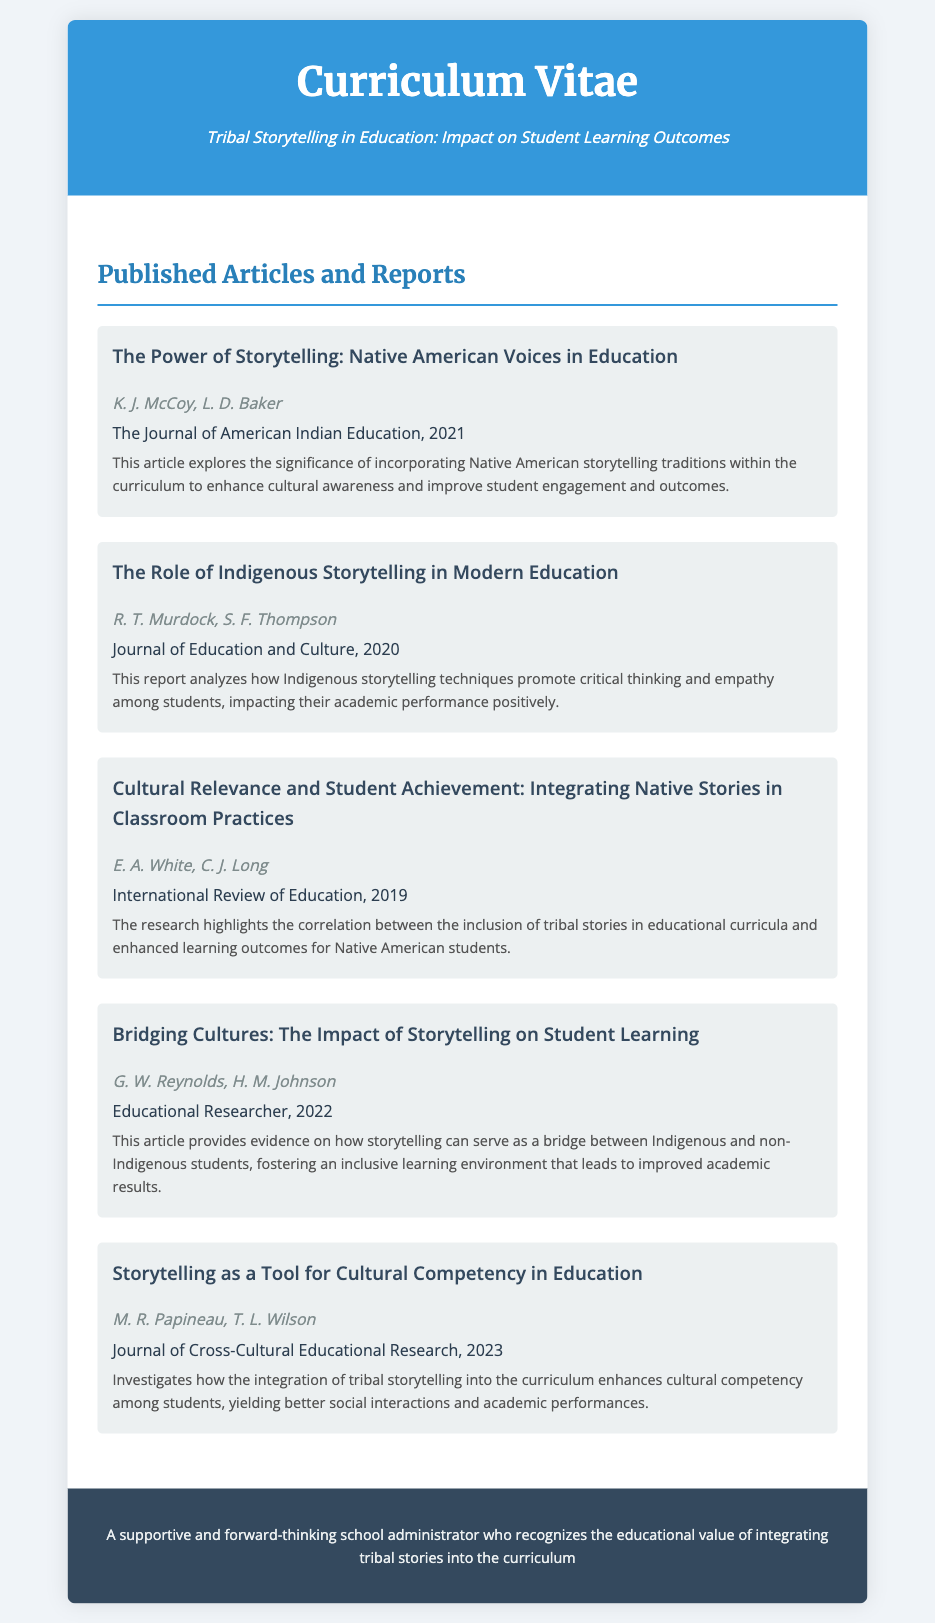What is the title of the first article? The title can be found at the beginning of the article section, listing the relevant information.
Answer: The Power of Storytelling: Native American Voices in Education Who are the authors of the article published in 2023? The authors can be identified under the respective article title, specifically for the published year mentioned.
Answer: M. R. Papineau, T. L. Wilson In what year was the article "Cultural Relevance and Student Achievement: Integrating Native Stories in Classroom Practices" published? This information is stated directly after the title of the article in the document.
Answer: 2019 Which journal published the report analyzing Indigenous storytelling techniques? The journal's name is mentioned after the article title and authors, relevant to the specific report.
Answer: Journal of Education and Culture What is a key outcome of integrating tribal storytelling into education according to the articles? This insight can be gathered from the impact descriptions under each article, reflecting overall findings.
Answer: Enhanced cultural awareness How many articles were published in the year 2021? Counting the articles listed in the document is necessary to arrive at this number.
Answer: 1 What common theme is present in the articles listed? The common theme can be derived by looking at the impact or focus described in the articles.
Answer: Tribal storytelling in education Which article discusses the impact of storytelling on bridging cultures? The document provides the title of the article, allowing for easy identification based on the described focus.
Answer: Bridging Cultures: The Impact of Storytelling on Student Learning What publication appears in the footer of the document? The footer usually contains a description of the author's role or philosophy, can be identified easily.
Answer: A supportive and forward-thinking school administrator who recognizes the educational value of integrating tribal stories into the curriculum 